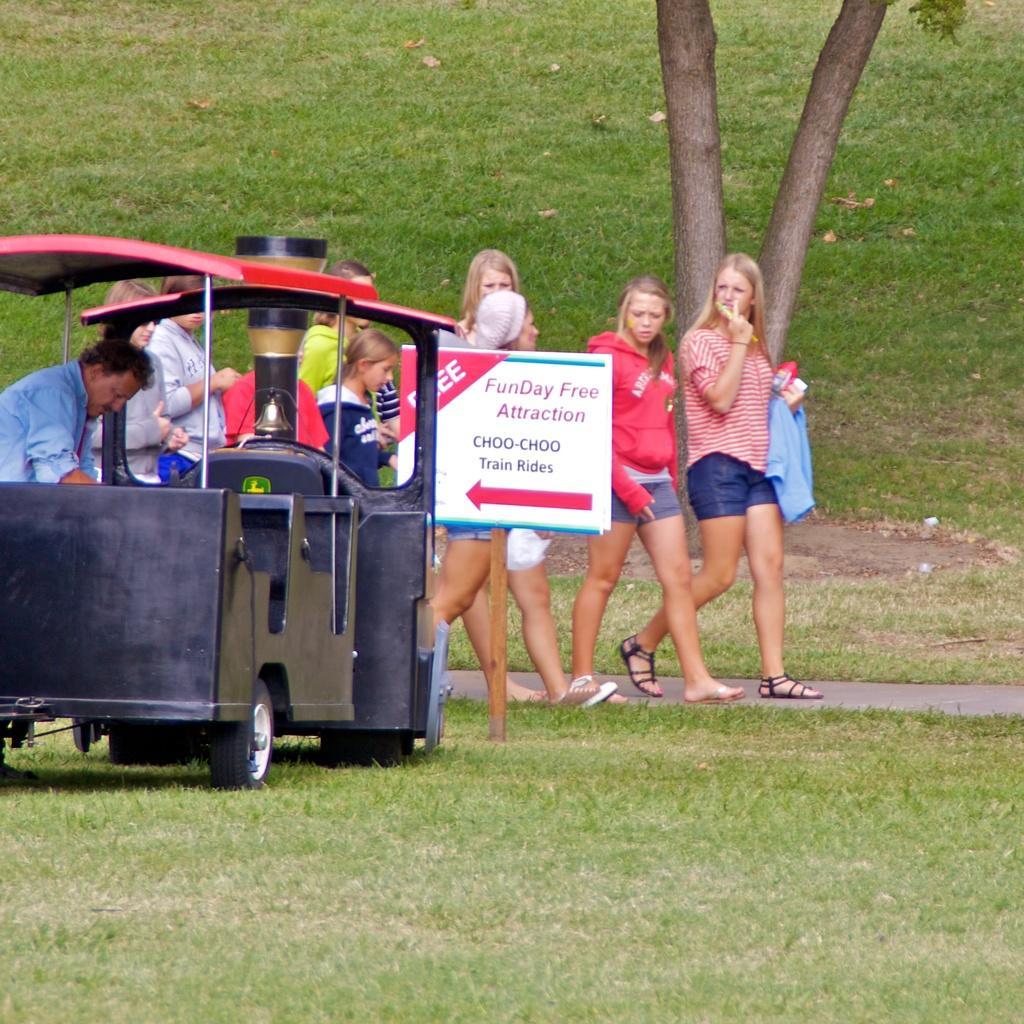Can you describe this image briefly? In this image there are persons walking in the center and on the left side there is a man and there is a vehicle which is black in colour, and there is a board with some text written on it. On the ground there is grass and there is a tree. 